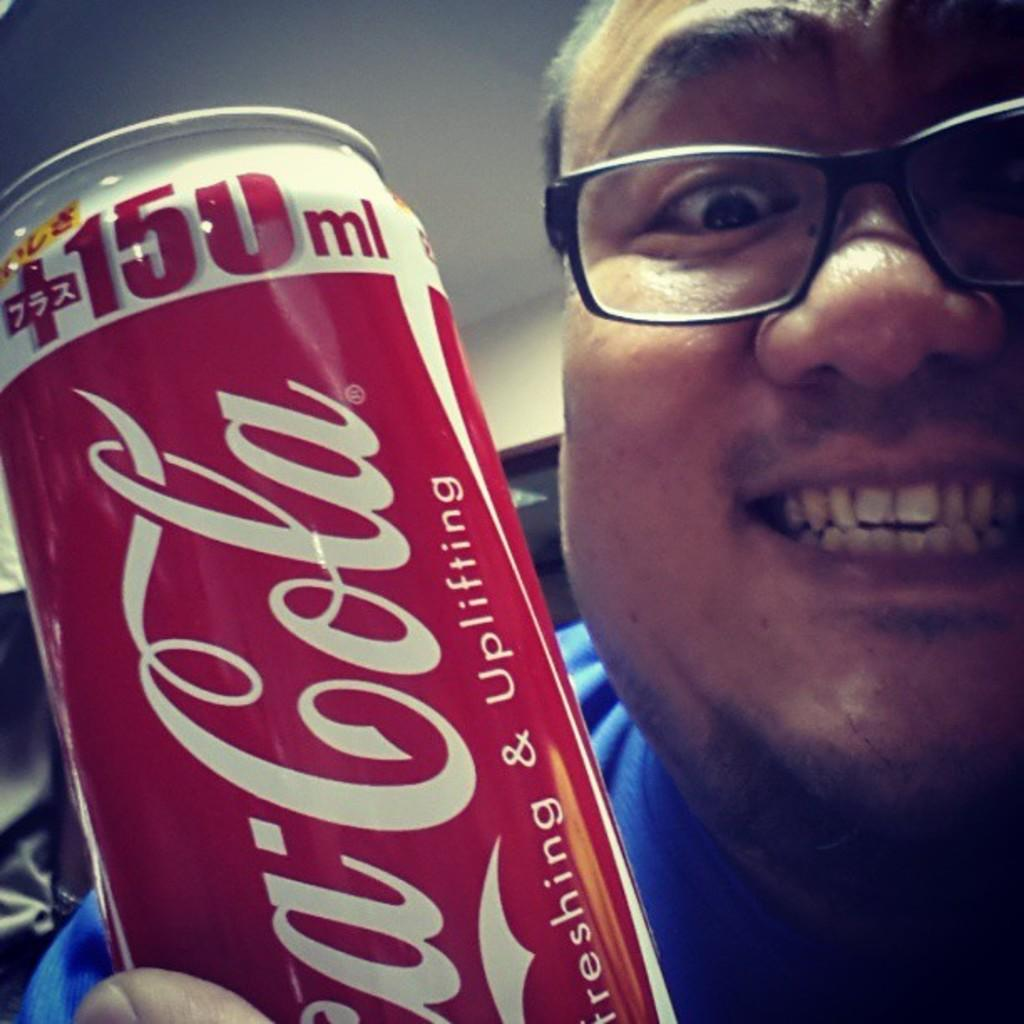<image>
Give a short and clear explanation of the subsequent image. A smiling man holds up a can of Coca Cola. 